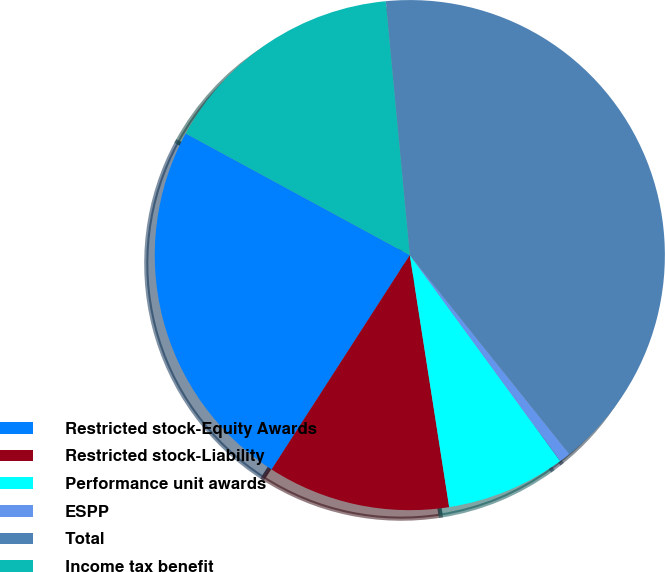<chart> <loc_0><loc_0><loc_500><loc_500><pie_chart><fcel>Restricted stock-Equity Awards<fcel>Restricted stock-Liability<fcel>Performance unit awards<fcel>ESPP<fcel>Total<fcel>Income tax benefit<nl><fcel>23.8%<fcel>11.58%<fcel>7.57%<fcel>0.72%<fcel>40.75%<fcel>15.58%<nl></chart> 